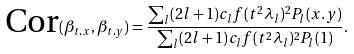<formula> <loc_0><loc_0><loc_500><loc_500>\text {Cor} ( \beta _ { t , x } , \beta _ { t , y } ) = \frac { \sum _ { l } ( 2 l + 1 ) c _ { l } f ( t ^ { 2 } \lambda _ { l } ) ^ { 2 } P _ { l } ( x . y ) } { \sum _ { l } ( 2 l + 1 ) c _ { l } f ( t ^ { 2 } \lambda _ { l } ) ^ { 2 } P _ { l } ( 1 ) } .</formula> 